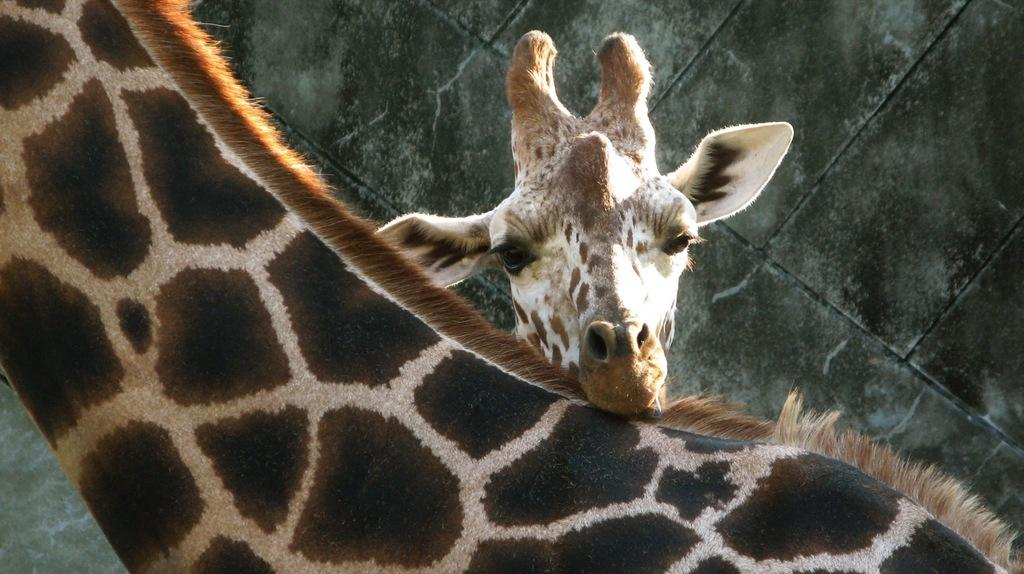How many giraffes are present in the image? There are two giraffes in the image. What can be seen in the background of the image? There is a wall in the background of the image. What type of coil is being used by the giraffes in the image? There is no coil present in the image; it features two giraffes and a wall in the background. 